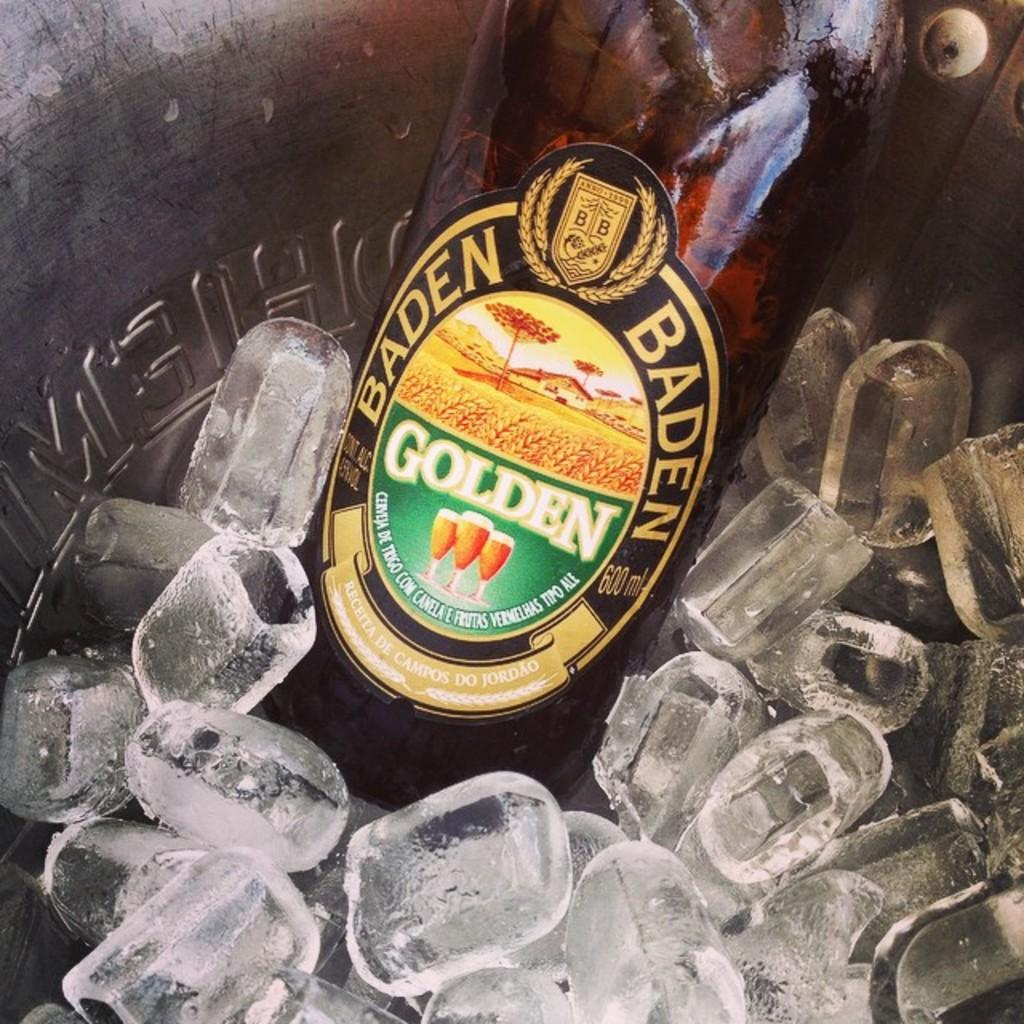<image>
Write a terse but informative summary of the picture. A bottle of Golden Baden Baden is chilling on ice. 